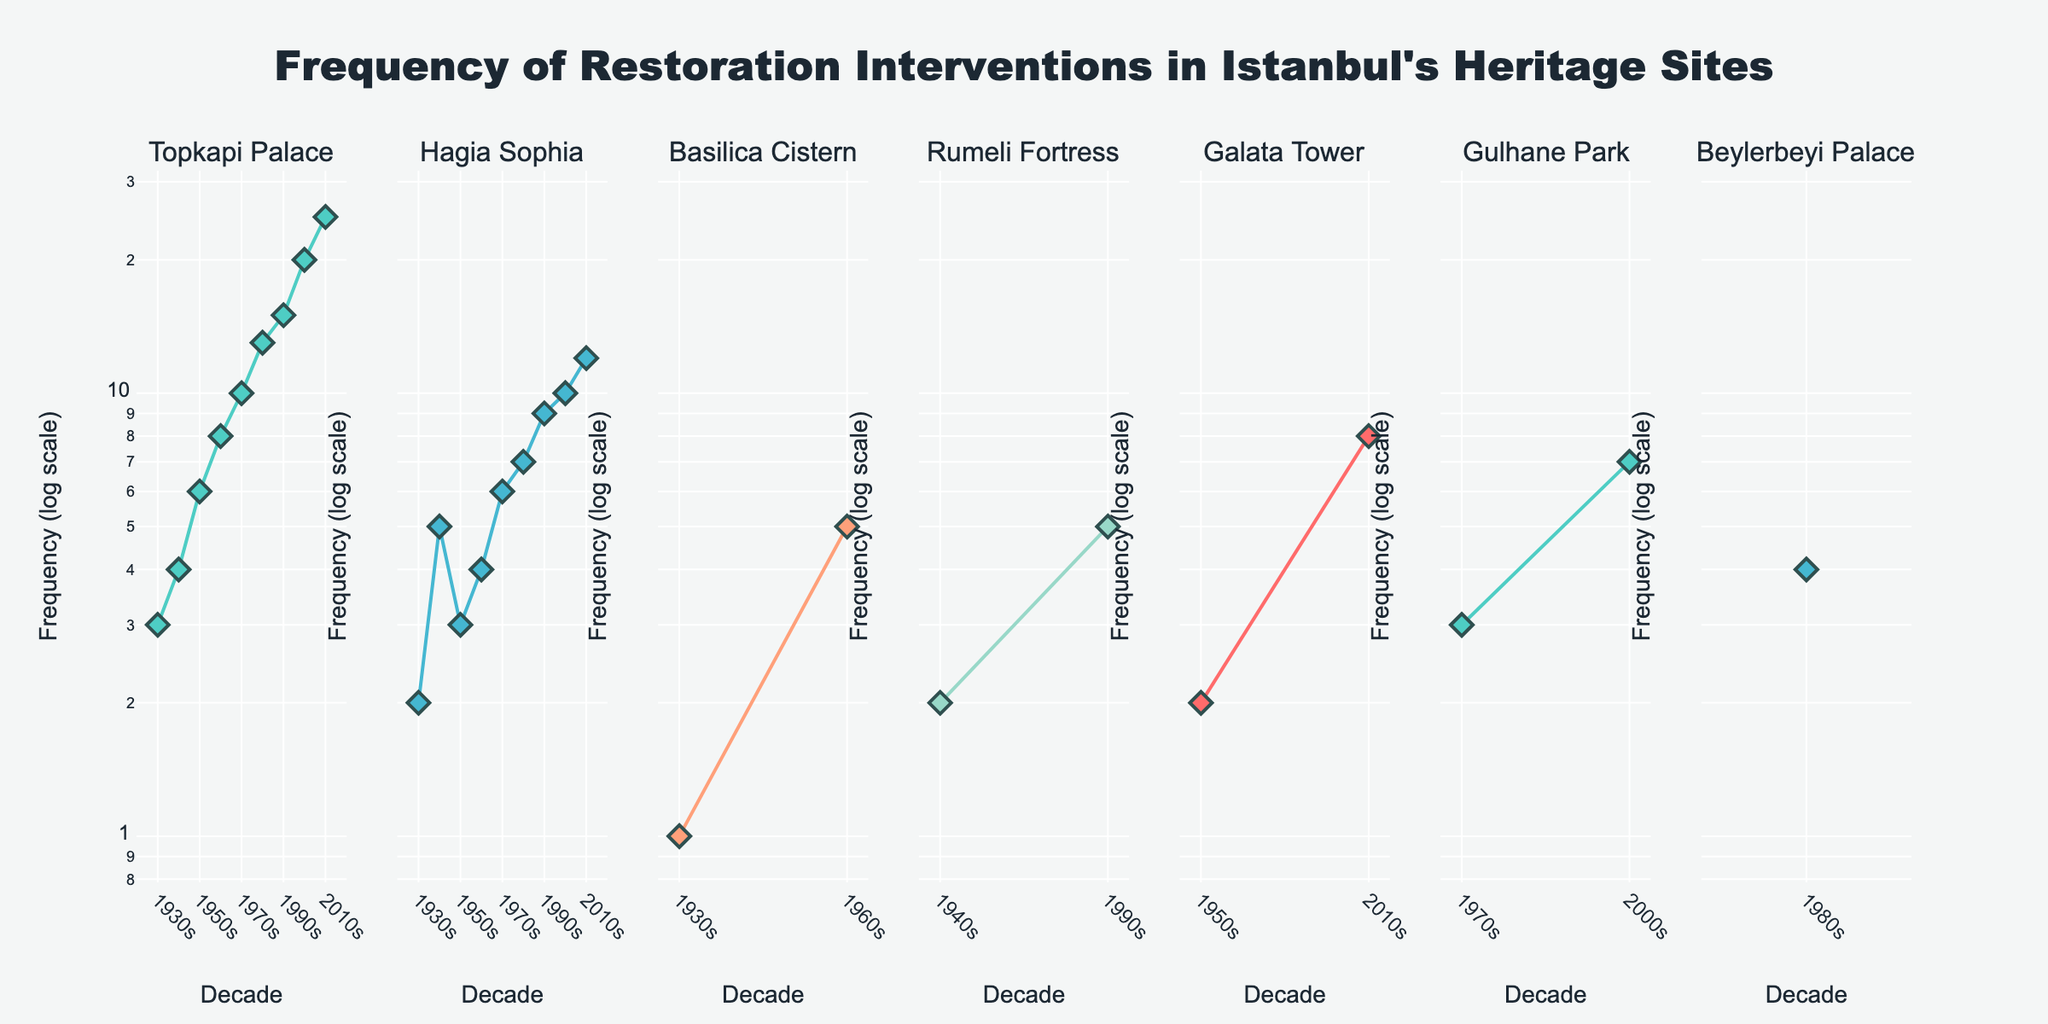What is the title of the figure? The title is displayed prominently at the top center of the figure. It reads "Frequency of Restoration Interventions in Istanbul's Heritage Sites".
Answer: Frequency of Restoration Interventions in Istanbul's Heritage Sites How many heritage sites are plotted in the figure? The subplots are titled with each heritage site's name at the top of each subplot. By counting these titles, we can see there are six sites in total.
Answer: Six Which decade shows the highest frequency of restoration interventions for Topkapi Palace? By examining the 'Topkapi Palace' subplot, we identify the highest data point, which is in the 2010s with a frequency of 25.
Answer: 2010s In which decade did Hagia Sophia see the most frequency restorations, and what was the frequency? Refer to the subplot for 'Hagia Sophia' and look for the highest data point, which is in the 2010s with a frequency of 12.
Answer: 2010s, 12 Compare the frequency of restoration interventions in the 1940s between Hagia Sophia and Rumeli Fortress. Which site had more interventions, and what were their frequencies? Examine the 1940s data points in the 'Hagia Sophia' and 'Rumeli Fortress' subplots. Hagia Sophia had a frequency of 5, while Rumeli Fortress had a frequency of 2.
Answer: Hagia Sophia had more with 5 interventions What can you say about the trend of restoration interventions for Topkapi Palace from the 1930s to the 2010s? Observing the 'Topkapi Palace' subplot, we see an upward trend from a frequency of 3 in the 1930s to 25 in the 2010s. The frequency consistently increases each decade.
Answer: Upward trend Which heritage sites had interventions in the 1950s, and what were their frequencies? By checking the 1950s data points in each subplot, Topkapi Palace had 6, Hagia Sophia had 3, and Galata Tower had 2.
Answer: Topkapi Palace: 6, Hagia Sophia: 3, Galata Tower: 2 Which site displayed the lowest peak frequency across all decades? By identifying the highest frequency in each subplot and comparing them, the lowest peak frequency is 4 for 'Beylerbeyi Palace' in the 1980s.
Answer: Beylerbeyi Palace How did the frequency of restorations for Basilica Cistern change from the 1930s to the 1960s? For 'Basilica Cistern', the frequency was 1 in the 1930s and increased to 5 in the 1960s. This indicates an upward trend from the 1930s to the 1960s.
Answer: Increased from 1 to 5 